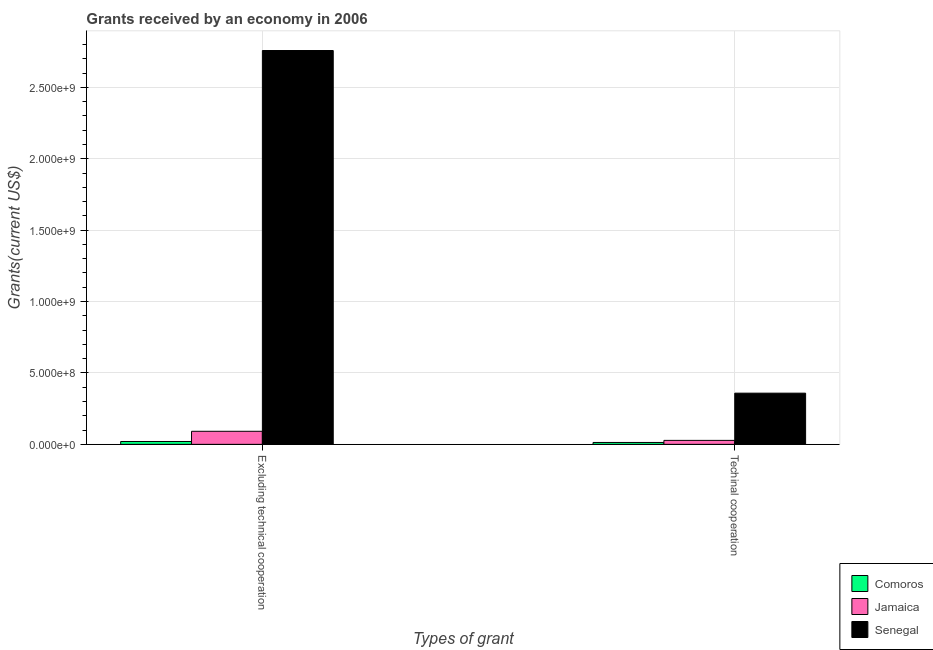How many different coloured bars are there?
Give a very brief answer. 3. How many groups of bars are there?
Ensure brevity in your answer.  2. Are the number of bars per tick equal to the number of legend labels?
Ensure brevity in your answer.  Yes. Are the number of bars on each tick of the X-axis equal?
Ensure brevity in your answer.  Yes. How many bars are there on the 2nd tick from the left?
Your answer should be very brief. 3. How many bars are there on the 2nd tick from the right?
Keep it short and to the point. 3. What is the label of the 2nd group of bars from the left?
Your answer should be very brief. Techinal cooperation. What is the amount of grants received(including technical cooperation) in Comoros?
Give a very brief answer. 1.33e+07. Across all countries, what is the maximum amount of grants received(excluding technical cooperation)?
Make the answer very short. 2.76e+09. Across all countries, what is the minimum amount of grants received(excluding technical cooperation)?
Your answer should be very brief. 2.00e+07. In which country was the amount of grants received(excluding technical cooperation) maximum?
Make the answer very short. Senegal. In which country was the amount of grants received(including technical cooperation) minimum?
Provide a short and direct response. Comoros. What is the total amount of grants received(excluding technical cooperation) in the graph?
Keep it short and to the point. 2.87e+09. What is the difference between the amount of grants received(excluding technical cooperation) in Senegal and that in Jamaica?
Keep it short and to the point. 2.67e+09. What is the difference between the amount of grants received(excluding technical cooperation) in Comoros and the amount of grants received(including technical cooperation) in Jamaica?
Your response must be concise. -7.85e+06. What is the average amount of grants received(including technical cooperation) per country?
Ensure brevity in your answer.  1.33e+08. What is the difference between the amount of grants received(excluding technical cooperation) and amount of grants received(including technical cooperation) in Jamaica?
Offer a terse response. 6.36e+07. What is the ratio of the amount of grants received(including technical cooperation) in Jamaica to that in Senegal?
Provide a short and direct response. 0.08. In how many countries, is the amount of grants received(including technical cooperation) greater than the average amount of grants received(including technical cooperation) taken over all countries?
Make the answer very short. 1. What does the 1st bar from the left in Techinal cooperation represents?
Offer a very short reply. Comoros. What does the 2nd bar from the right in Excluding technical cooperation represents?
Your answer should be very brief. Jamaica. How many countries are there in the graph?
Your response must be concise. 3. What is the difference between two consecutive major ticks on the Y-axis?
Your answer should be very brief. 5.00e+08. Does the graph contain any zero values?
Keep it short and to the point. No. Does the graph contain grids?
Your answer should be compact. Yes. Where does the legend appear in the graph?
Give a very brief answer. Bottom right. How are the legend labels stacked?
Offer a very short reply. Vertical. What is the title of the graph?
Keep it short and to the point. Grants received by an economy in 2006. What is the label or title of the X-axis?
Make the answer very short. Types of grant. What is the label or title of the Y-axis?
Keep it short and to the point. Grants(current US$). What is the Grants(current US$) in Comoros in Excluding technical cooperation?
Offer a terse response. 2.00e+07. What is the Grants(current US$) of Jamaica in Excluding technical cooperation?
Provide a short and direct response. 9.15e+07. What is the Grants(current US$) of Senegal in Excluding technical cooperation?
Make the answer very short. 2.76e+09. What is the Grants(current US$) of Comoros in Techinal cooperation?
Your answer should be compact. 1.33e+07. What is the Grants(current US$) of Jamaica in Techinal cooperation?
Your response must be concise. 2.79e+07. What is the Grants(current US$) in Senegal in Techinal cooperation?
Provide a succinct answer. 3.58e+08. Across all Types of grant, what is the maximum Grants(current US$) in Comoros?
Your answer should be compact. 2.00e+07. Across all Types of grant, what is the maximum Grants(current US$) of Jamaica?
Provide a short and direct response. 9.15e+07. Across all Types of grant, what is the maximum Grants(current US$) of Senegal?
Your answer should be very brief. 2.76e+09. Across all Types of grant, what is the minimum Grants(current US$) of Comoros?
Give a very brief answer. 1.33e+07. Across all Types of grant, what is the minimum Grants(current US$) in Jamaica?
Provide a succinct answer. 2.79e+07. Across all Types of grant, what is the minimum Grants(current US$) in Senegal?
Make the answer very short. 3.58e+08. What is the total Grants(current US$) of Comoros in the graph?
Your answer should be compact. 3.33e+07. What is the total Grants(current US$) in Jamaica in the graph?
Keep it short and to the point. 1.19e+08. What is the total Grants(current US$) of Senegal in the graph?
Provide a short and direct response. 3.12e+09. What is the difference between the Grants(current US$) in Comoros in Excluding technical cooperation and that in Techinal cooperation?
Your answer should be compact. 6.72e+06. What is the difference between the Grants(current US$) in Jamaica in Excluding technical cooperation and that in Techinal cooperation?
Your answer should be very brief. 6.36e+07. What is the difference between the Grants(current US$) in Senegal in Excluding technical cooperation and that in Techinal cooperation?
Provide a short and direct response. 2.40e+09. What is the difference between the Grants(current US$) in Comoros in Excluding technical cooperation and the Grants(current US$) in Jamaica in Techinal cooperation?
Keep it short and to the point. -7.85e+06. What is the difference between the Grants(current US$) in Comoros in Excluding technical cooperation and the Grants(current US$) in Senegal in Techinal cooperation?
Your answer should be very brief. -3.38e+08. What is the difference between the Grants(current US$) in Jamaica in Excluding technical cooperation and the Grants(current US$) in Senegal in Techinal cooperation?
Your answer should be compact. -2.67e+08. What is the average Grants(current US$) of Comoros per Types of grant?
Make the answer very short. 1.66e+07. What is the average Grants(current US$) in Jamaica per Types of grant?
Provide a succinct answer. 5.97e+07. What is the average Grants(current US$) of Senegal per Types of grant?
Your answer should be very brief. 1.56e+09. What is the difference between the Grants(current US$) of Comoros and Grants(current US$) of Jamaica in Excluding technical cooperation?
Give a very brief answer. -7.15e+07. What is the difference between the Grants(current US$) in Comoros and Grants(current US$) in Senegal in Excluding technical cooperation?
Offer a very short reply. -2.74e+09. What is the difference between the Grants(current US$) in Jamaica and Grants(current US$) in Senegal in Excluding technical cooperation?
Your response must be concise. -2.67e+09. What is the difference between the Grants(current US$) of Comoros and Grants(current US$) of Jamaica in Techinal cooperation?
Make the answer very short. -1.46e+07. What is the difference between the Grants(current US$) in Comoros and Grants(current US$) in Senegal in Techinal cooperation?
Your answer should be compact. -3.45e+08. What is the difference between the Grants(current US$) of Jamaica and Grants(current US$) of Senegal in Techinal cooperation?
Ensure brevity in your answer.  -3.31e+08. What is the ratio of the Grants(current US$) in Comoros in Excluding technical cooperation to that in Techinal cooperation?
Give a very brief answer. 1.51. What is the ratio of the Grants(current US$) in Jamaica in Excluding technical cooperation to that in Techinal cooperation?
Your answer should be very brief. 3.28. What is the ratio of the Grants(current US$) in Senegal in Excluding technical cooperation to that in Techinal cooperation?
Your response must be concise. 7.69. What is the difference between the highest and the second highest Grants(current US$) of Comoros?
Make the answer very short. 6.72e+06. What is the difference between the highest and the second highest Grants(current US$) in Jamaica?
Keep it short and to the point. 6.36e+07. What is the difference between the highest and the second highest Grants(current US$) of Senegal?
Your response must be concise. 2.40e+09. What is the difference between the highest and the lowest Grants(current US$) in Comoros?
Offer a very short reply. 6.72e+06. What is the difference between the highest and the lowest Grants(current US$) of Jamaica?
Ensure brevity in your answer.  6.36e+07. What is the difference between the highest and the lowest Grants(current US$) in Senegal?
Offer a very short reply. 2.40e+09. 